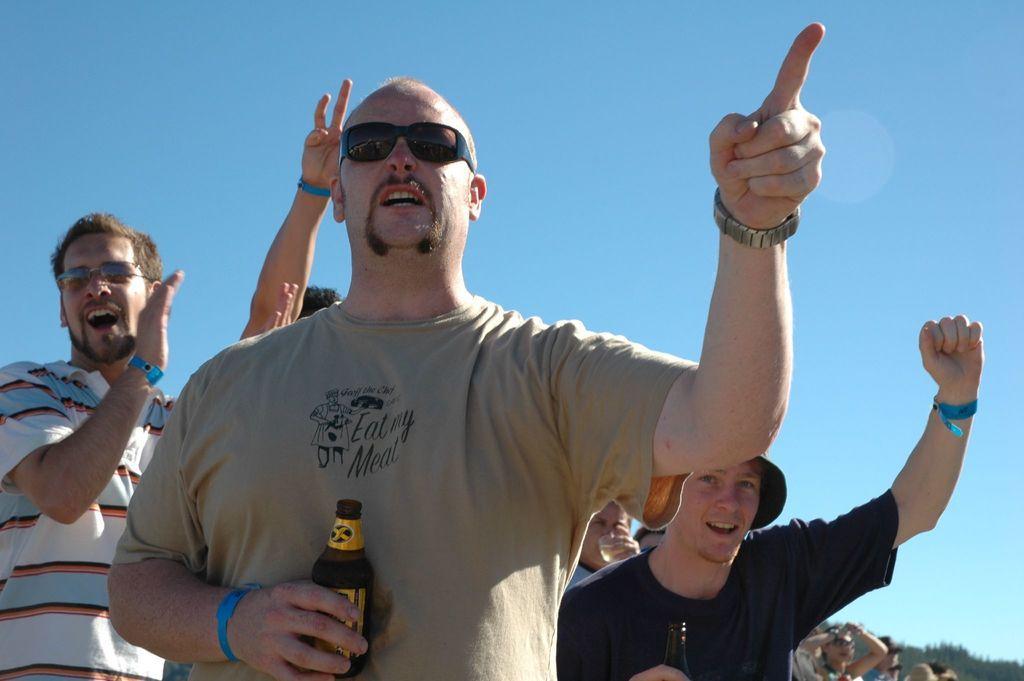How would you summarize this image in a sentence or two? In this image I see 4 men in which this man is holding a bottle in his hand and this man is holding a glass near to his mouth and I see that these both are wearing shades and this man is wearing a cap. In the background I see few more people and I see the blue sky. 